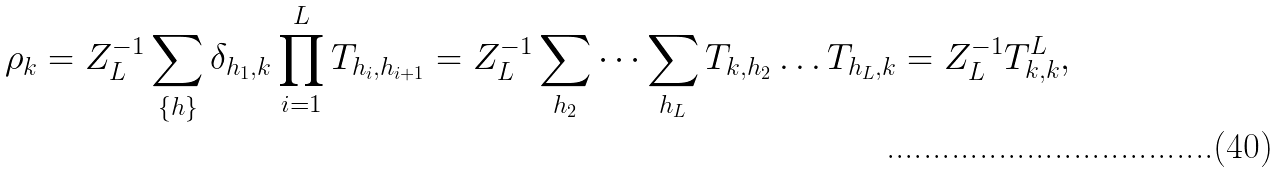Convert formula to latex. <formula><loc_0><loc_0><loc_500><loc_500>\rho _ { k } = Z _ { L } ^ { - 1 } \sum _ { \{ h \} } \delta _ { h _ { 1 } , k } \prod _ { i = 1 } ^ { L } T _ { h _ { i } , h _ { i + 1 } } = Z _ { L } ^ { - 1 } \sum _ { h _ { 2 } } \dots \sum _ { h _ { L } } T _ { k , h _ { 2 } } \dots T _ { h _ { L } , k } = Z _ { L } ^ { - 1 } T ^ { L } _ { k , k } ,</formula> 